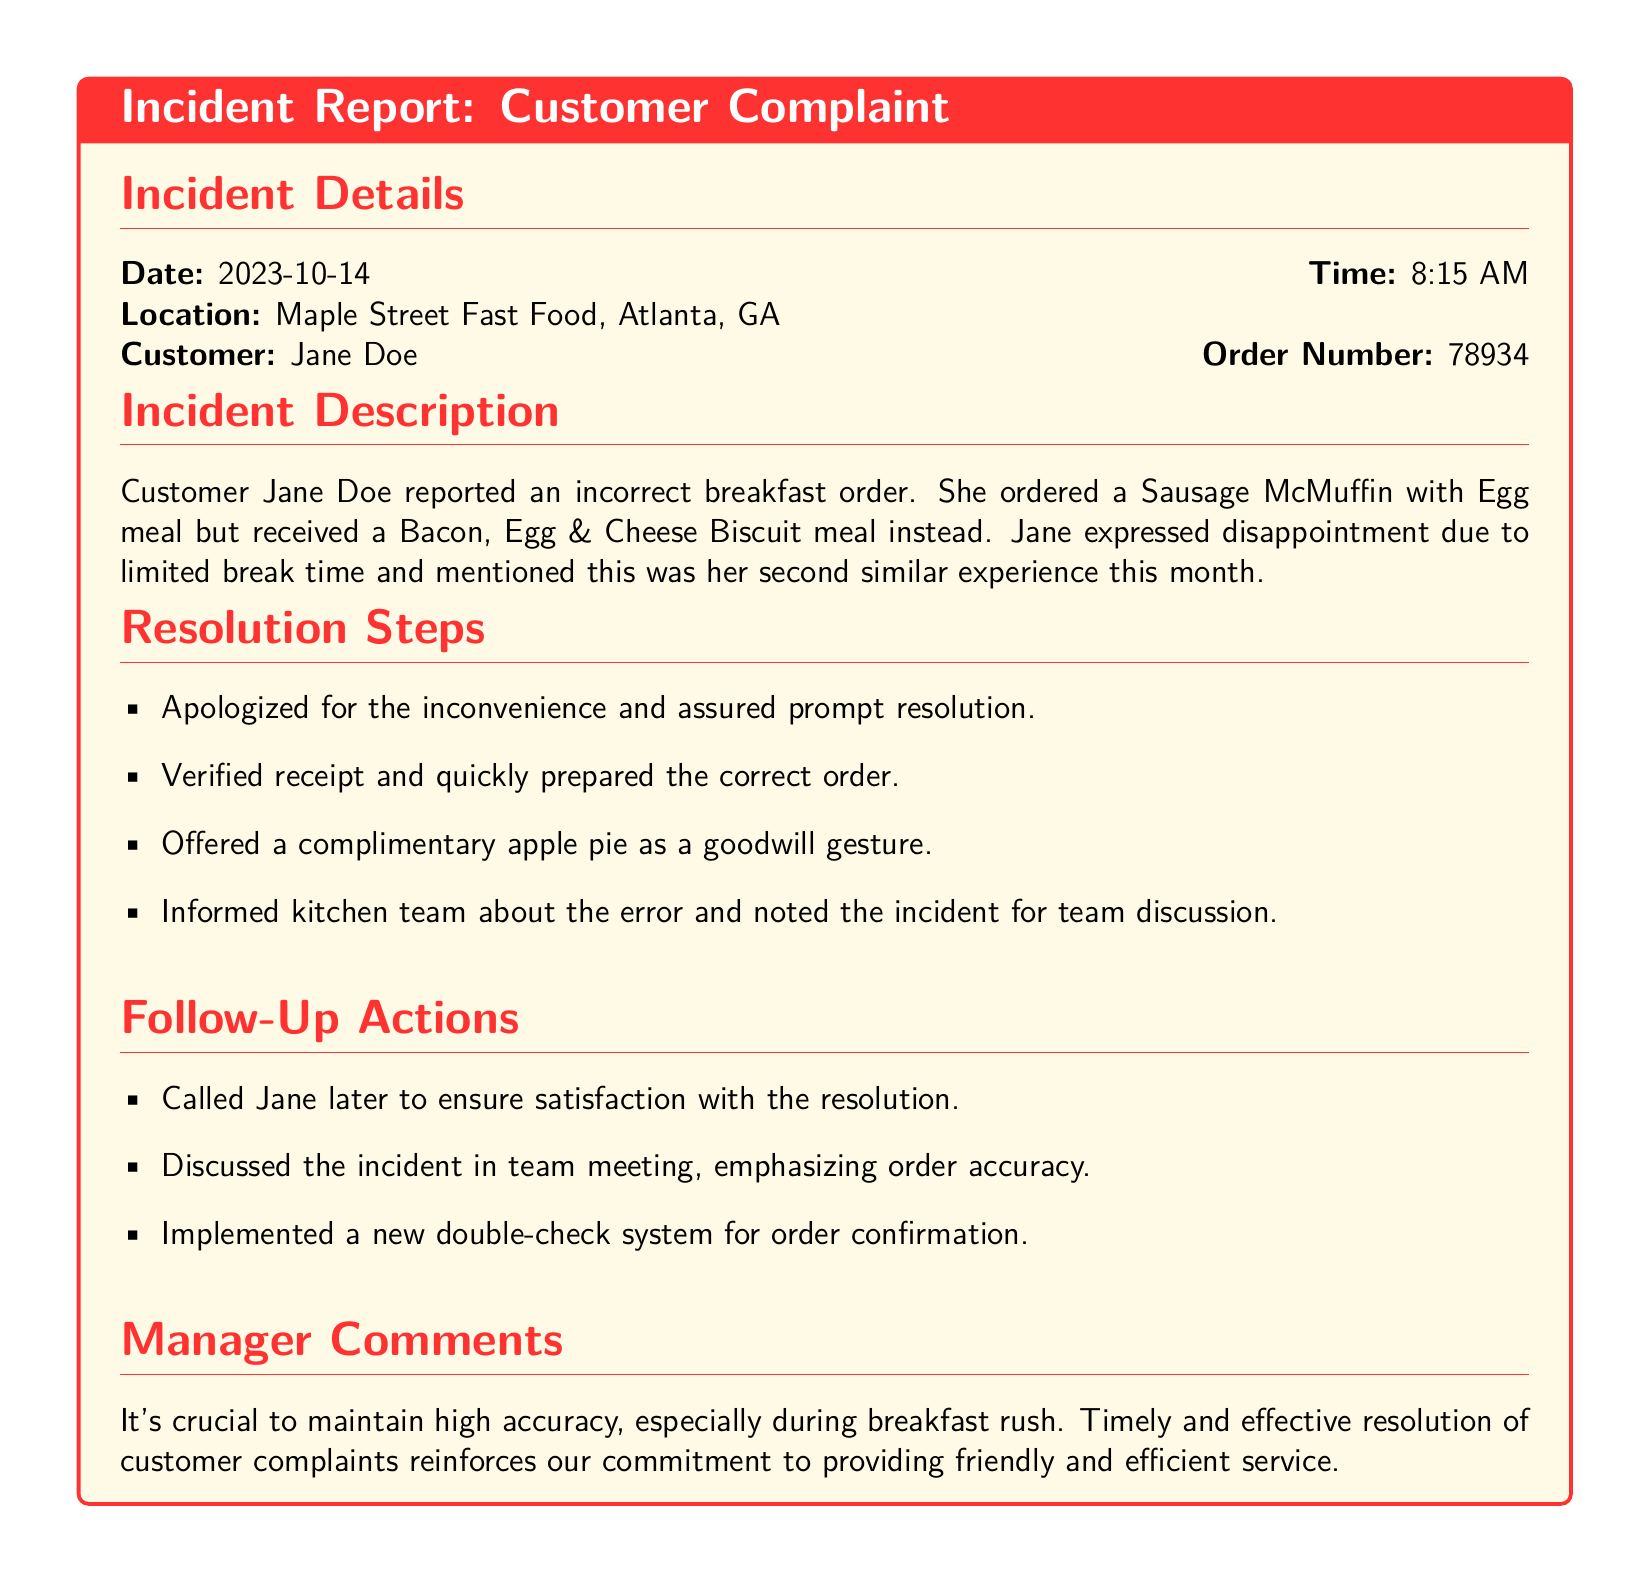What is the date of the incident? The date of the incident is mentioned in the document under incident details.
Answer: 2023-10-14 What time did the complaint occur? The time of the incident is specified in the incident details section of the report.
Answer: 8:15 AM Who was the customer that made the complaint? The customer's name is provided in the incident details of the report.
Answer: Jane Doe What was the incorrect food item received? The document outlines the specific incorrect order in the incident description.
Answer: Bacon, Egg & Cheese Biscuit What offered gesture was given to the customer? The resolution steps section mentions a goodwill gesture made to the customer.
Answer: Complimentary apple pie How many similar experiences did the customer have this month? The incident description indicates how many times the customer faced a similar issue recently.
Answer: Two What new system was implemented after the incident? The follow-up actions list mentions a procedural change to prevent future issues.
Answer: Double-check system for order confirmation What is the manager's sentiment regarding order accuracy? The manager's comments reflect the importance of a certain aspect of the service.
Answer: Crucial 